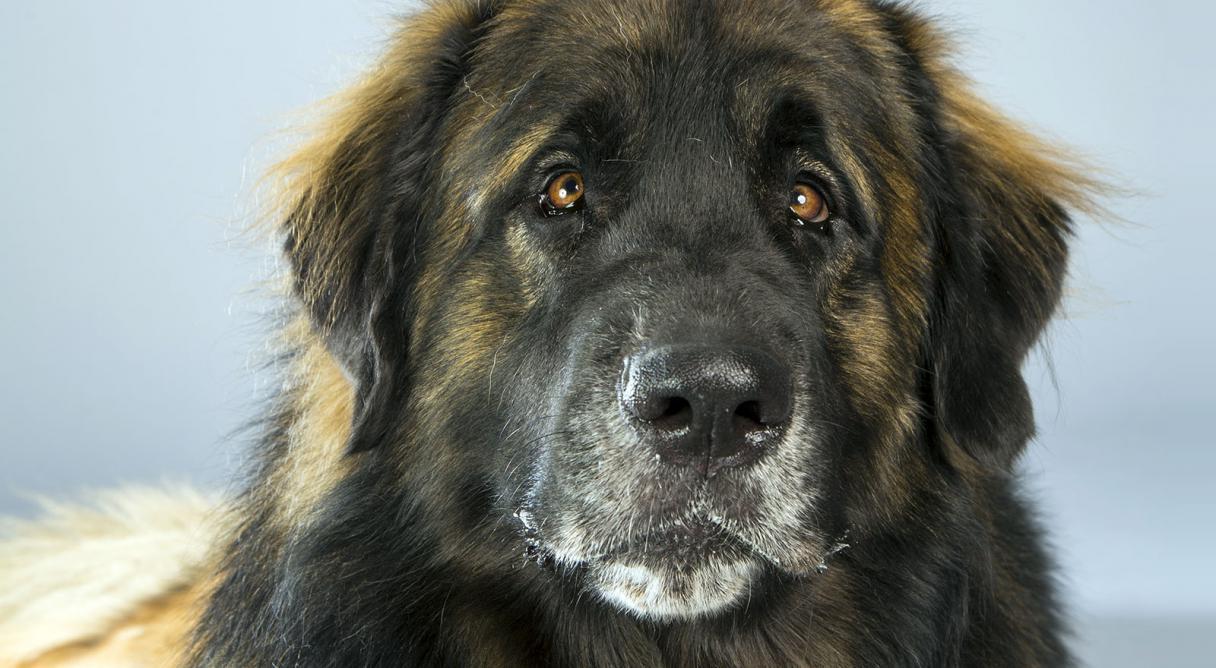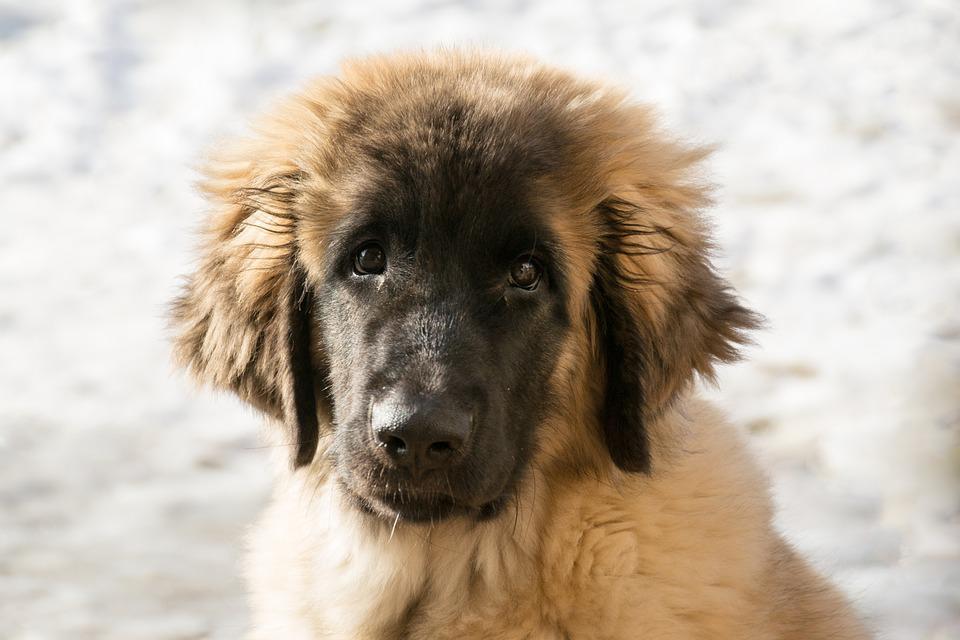The first image is the image on the left, the second image is the image on the right. Given the left and right images, does the statement "The dog in the right image is panting with its tongue hanging out." hold true? Answer yes or no. No. The first image is the image on the left, the second image is the image on the right. Considering the images on both sides, is "The dog's legs are not visible in any of the images." valid? Answer yes or no. Yes. 